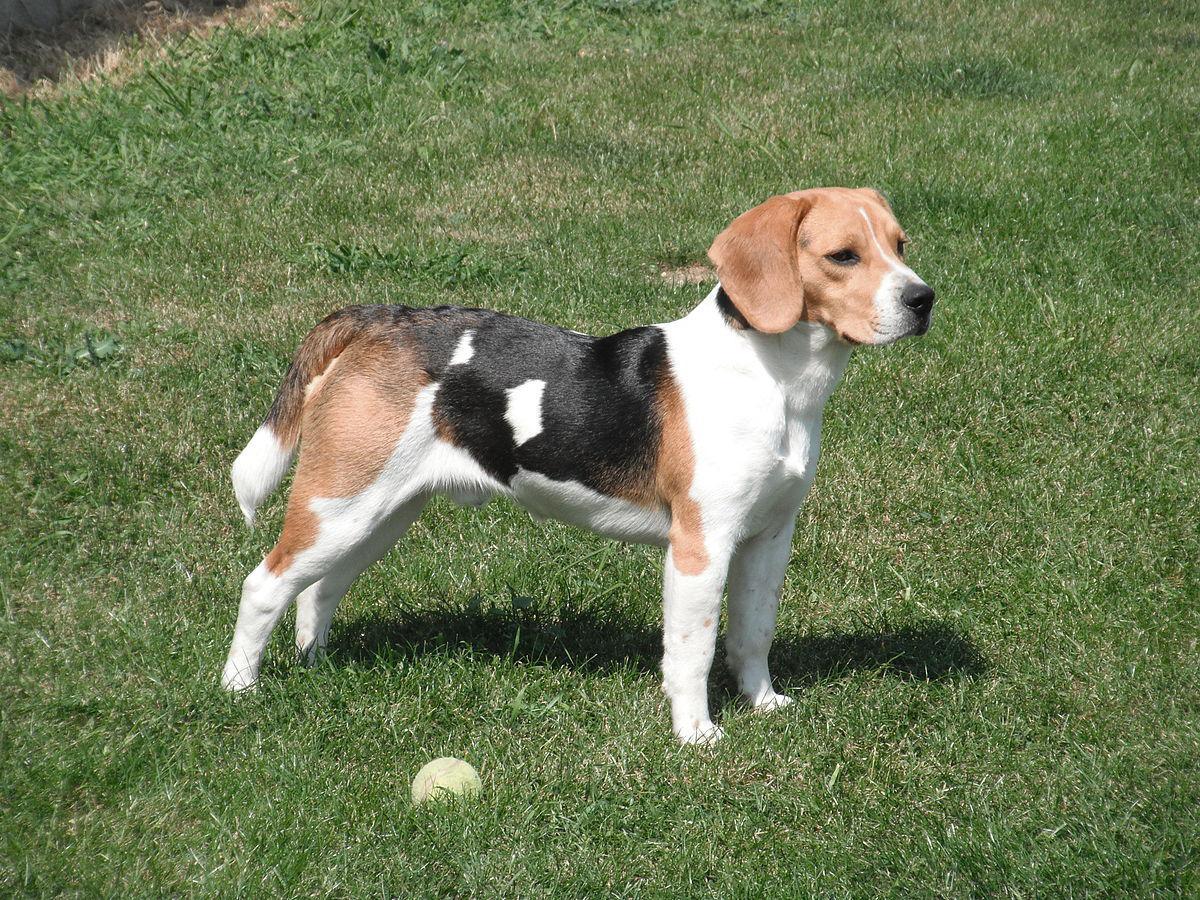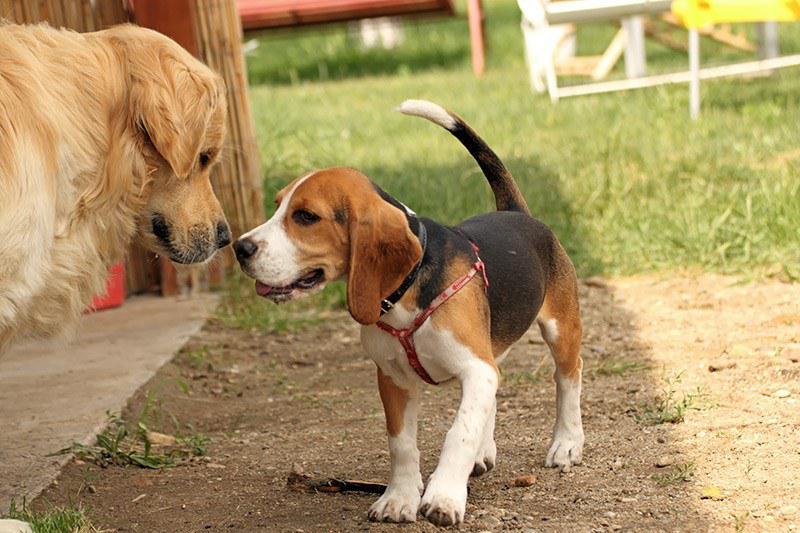The first image is the image on the left, the second image is the image on the right. Evaluate the accuracy of this statement regarding the images: "In total, images contain no more than three beagles.". Is it true? Answer yes or no. Yes. The first image is the image on the left, the second image is the image on the right. For the images displayed, is the sentence "At least one of the images shows three or more dogs." factually correct? Answer yes or no. No. 